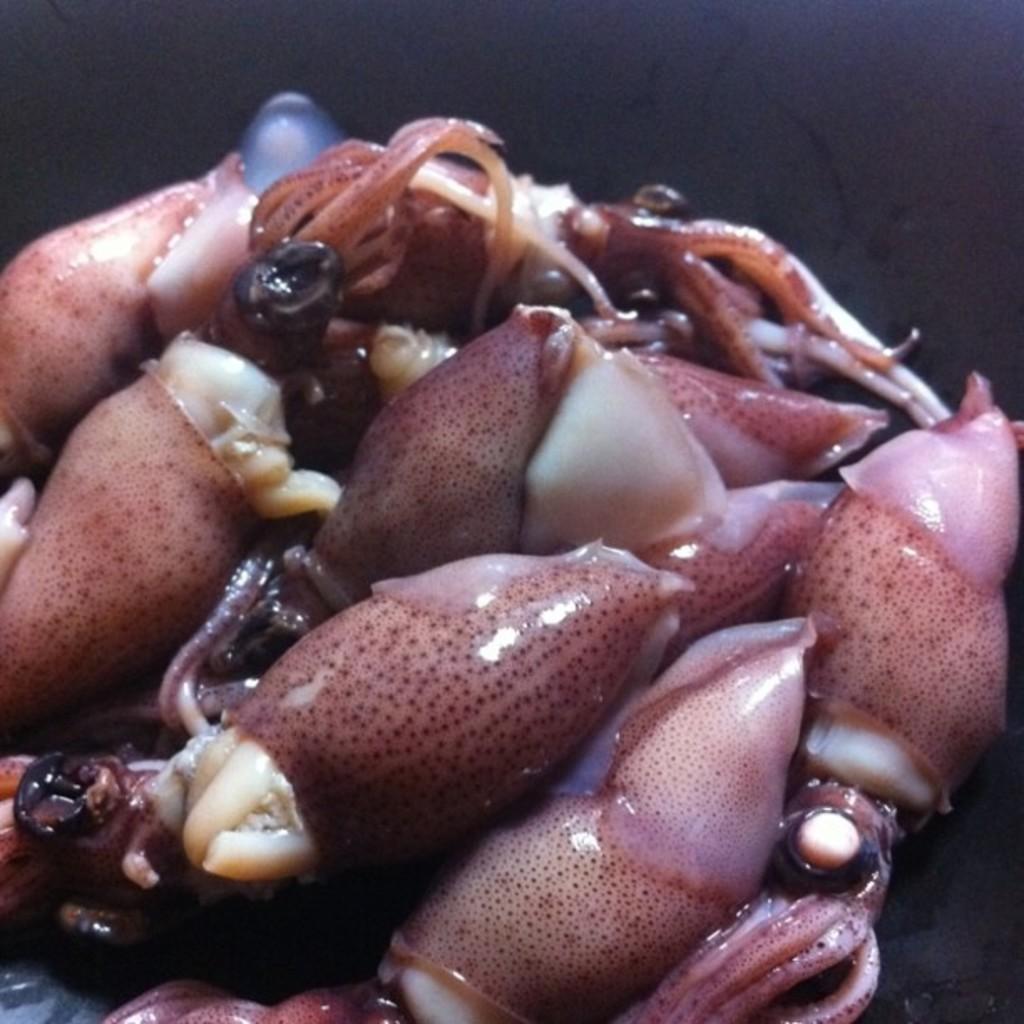Can you describe this image briefly? In the picture we can see a sea animals which are pink in color with some dots on it. 